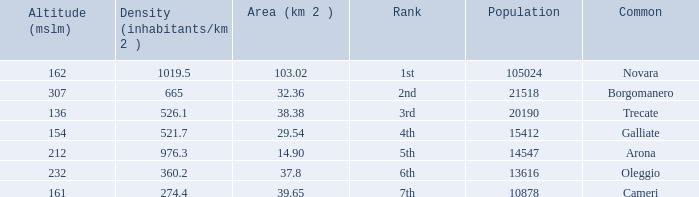What is the minimum altitude (mslm) in all the commons? 136.0. 